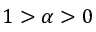<formula> <loc_0><loc_0><loc_500><loc_500>1 > \alpha > 0</formula> 